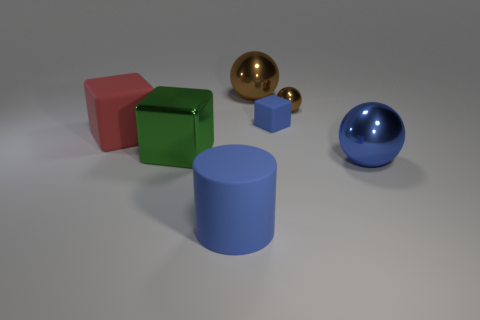Add 2 yellow metallic objects. How many objects exist? 9 Subtract all blocks. How many objects are left? 4 Add 1 small brown balls. How many small brown balls are left? 2 Add 4 big cyan matte blocks. How many big cyan matte blocks exist? 4 Subtract 0 red spheres. How many objects are left? 7 Subtract all blue objects. Subtract all small blue cubes. How many objects are left? 3 